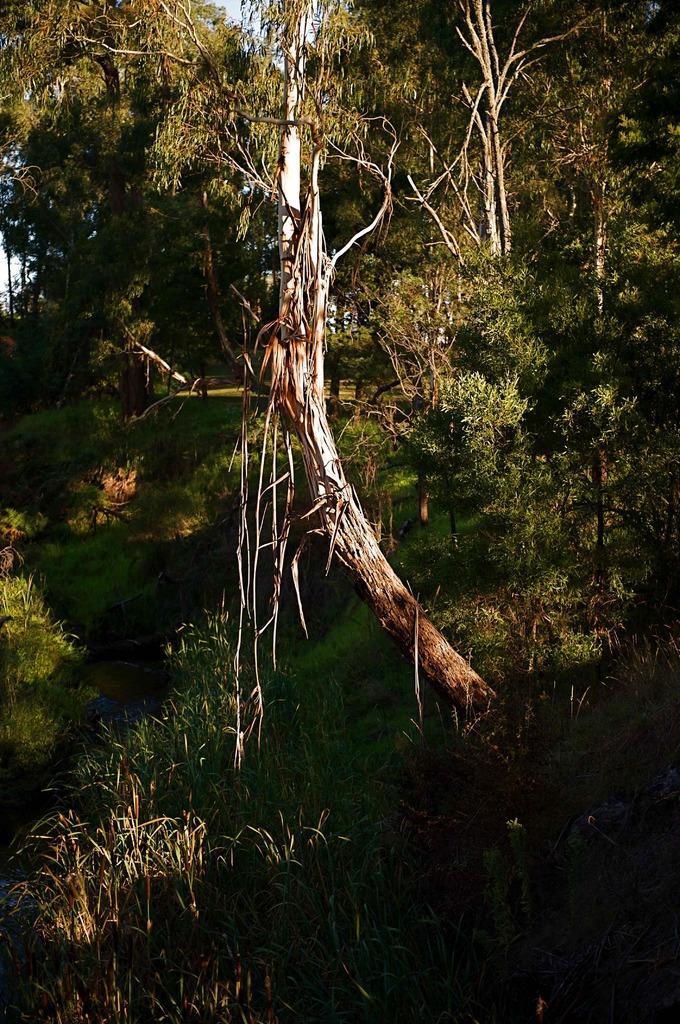Could you give a brief overview of what you see in this image? In this image, I can see the trees with branches and leaves. At the bottom of the image, I can see the grass. In the background, there is the sky. 